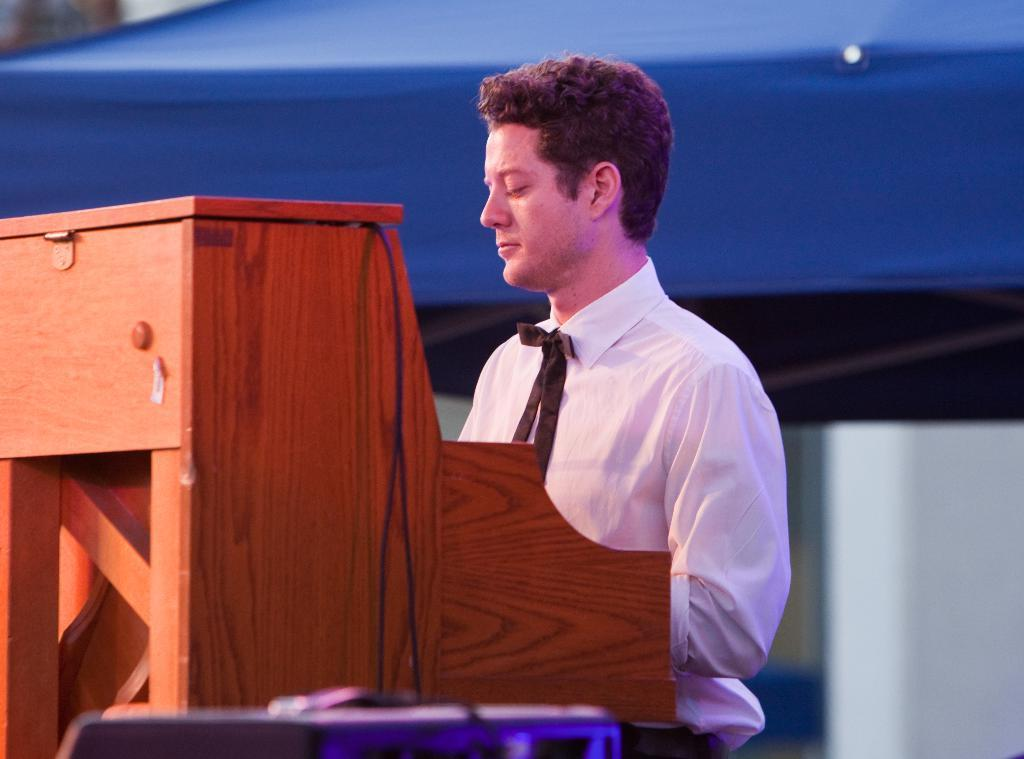Who is present in the image? There is a man in the image. What is the man wearing? The man is wearing a white shirt. What type of structure can be seen in the image? There is a wooden structure in the image. What advice does the man's grandmother give him in the image? There is no mention of a grandmother or any advice in the image. 